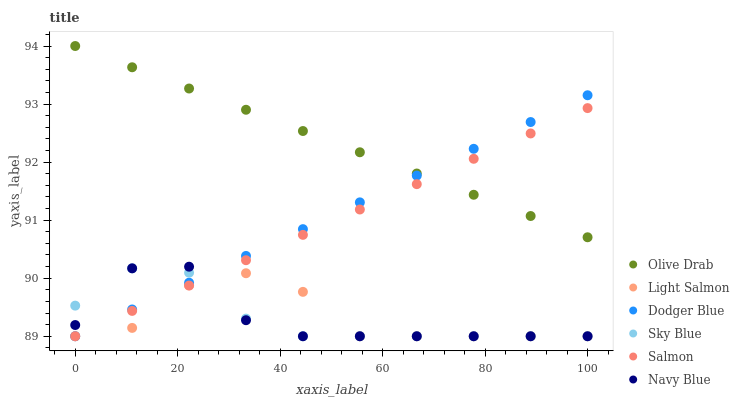Does Navy Blue have the minimum area under the curve?
Answer yes or no. Yes. Does Olive Drab have the maximum area under the curve?
Answer yes or no. Yes. Does Salmon have the minimum area under the curve?
Answer yes or no. No. Does Salmon have the maximum area under the curve?
Answer yes or no. No. Is Salmon the smoothest?
Answer yes or no. Yes. Is Light Salmon the roughest?
Answer yes or no. Yes. Is Navy Blue the smoothest?
Answer yes or no. No. Is Navy Blue the roughest?
Answer yes or no. No. Does Light Salmon have the lowest value?
Answer yes or no. Yes. Does Olive Drab have the lowest value?
Answer yes or no. No. Does Olive Drab have the highest value?
Answer yes or no. Yes. Does Navy Blue have the highest value?
Answer yes or no. No. Is Sky Blue less than Olive Drab?
Answer yes or no. Yes. Is Olive Drab greater than Navy Blue?
Answer yes or no. Yes. Does Salmon intersect Sky Blue?
Answer yes or no. Yes. Is Salmon less than Sky Blue?
Answer yes or no. No. Is Salmon greater than Sky Blue?
Answer yes or no. No. Does Sky Blue intersect Olive Drab?
Answer yes or no. No. 